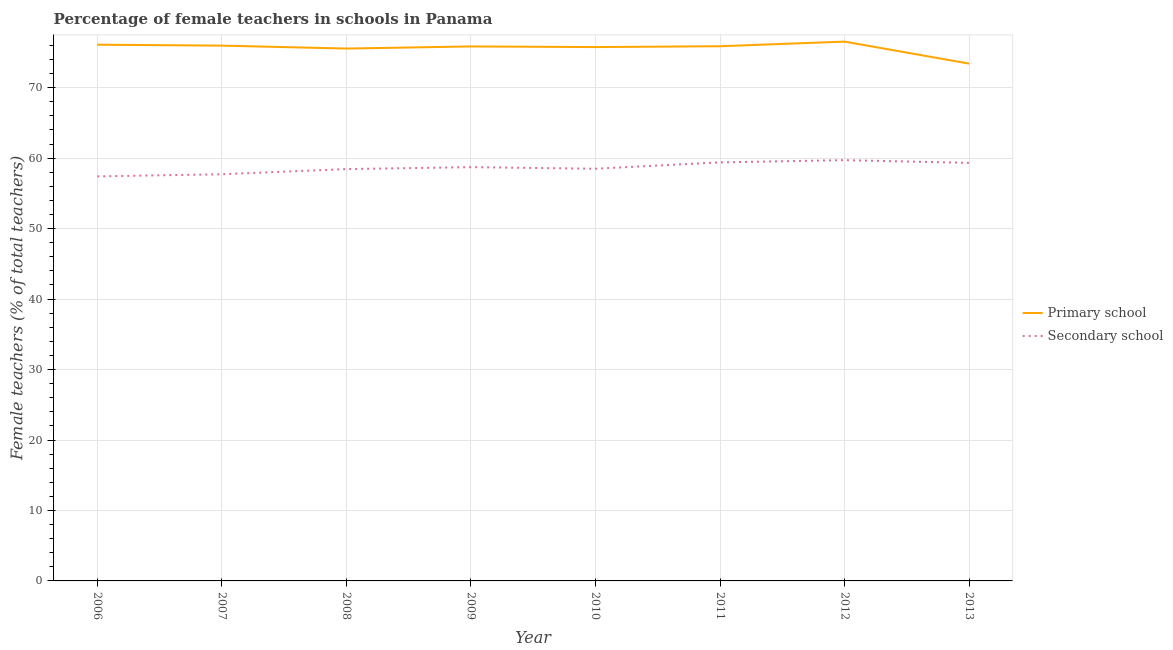What is the percentage of female teachers in secondary schools in 2010?
Offer a terse response. 58.5. Across all years, what is the maximum percentage of female teachers in primary schools?
Provide a short and direct response. 76.54. Across all years, what is the minimum percentage of female teachers in primary schools?
Your answer should be very brief. 73.42. What is the total percentage of female teachers in primary schools in the graph?
Give a very brief answer. 605.1. What is the difference between the percentage of female teachers in primary schools in 2007 and that in 2011?
Your answer should be very brief. 0.09. What is the difference between the percentage of female teachers in primary schools in 2006 and the percentage of female teachers in secondary schools in 2013?
Make the answer very short. 16.77. What is the average percentage of female teachers in primary schools per year?
Your answer should be very brief. 75.64. In the year 2012, what is the difference between the percentage of female teachers in primary schools and percentage of female teachers in secondary schools?
Your answer should be compact. 16.82. What is the ratio of the percentage of female teachers in secondary schools in 2010 to that in 2011?
Offer a very short reply. 0.98. Is the percentage of female teachers in secondary schools in 2007 less than that in 2008?
Provide a short and direct response. Yes. Is the difference between the percentage of female teachers in primary schools in 2009 and 2012 greater than the difference between the percentage of female teachers in secondary schools in 2009 and 2012?
Provide a short and direct response. Yes. What is the difference between the highest and the second highest percentage of female teachers in secondary schools?
Provide a succinct answer. 0.32. What is the difference between the highest and the lowest percentage of female teachers in secondary schools?
Offer a very short reply. 2.31. Is the sum of the percentage of female teachers in secondary schools in 2006 and 2013 greater than the maximum percentage of female teachers in primary schools across all years?
Provide a short and direct response. Yes. Does the percentage of female teachers in secondary schools monotonically increase over the years?
Offer a terse response. No. Is the percentage of female teachers in secondary schools strictly greater than the percentage of female teachers in primary schools over the years?
Offer a very short reply. No. Is the percentage of female teachers in secondary schools strictly less than the percentage of female teachers in primary schools over the years?
Make the answer very short. Yes. What is the difference between two consecutive major ticks on the Y-axis?
Provide a succinct answer. 10. Are the values on the major ticks of Y-axis written in scientific E-notation?
Ensure brevity in your answer.  No. Does the graph contain grids?
Your answer should be very brief. Yes. What is the title of the graph?
Ensure brevity in your answer.  Percentage of female teachers in schools in Panama. What is the label or title of the X-axis?
Make the answer very short. Year. What is the label or title of the Y-axis?
Your answer should be compact. Female teachers (% of total teachers). What is the Female teachers (% of total teachers) of Primary school in 2006?
Your answer should be very brief. 76.1. What is the Female teachers (% of total teachers) of Secondary school in 2006?
Give a very brief answer. 57.41. What is the Female teachers (% of total teachers) in Primary school in 2007?
Give a very brief answer. 75.97. What is the Female teachers (% of total teachers) of Secondary school in 2007?
Ensure brevity in your answer.  57.72. What is the Female teachers (% of total teachers) in Primary school in 2008?
Your response must be concise. 75.56. What is the Female teachers (% of total teachers) of Secondary school in 2008?
Offer a very short reply. 58.45. What is the Female teachers (% of total teachers) in Primary school in 2009?
Your response must be concise. 75.86. What is the Female teachers (% of total teachers) in Secondary school in 2009?
Make the answer very short. 58.72. What is the Female teachers (% of total teachers) in Primary school in 2010?
Your answer should be compact. 75.77. What is the Female teachers (% of total teachers) in Secondary school in 2010?
Provide a short and direct response. 58.5. What is the Female teachers (% of total teachers) in Primary school in 2011?
Your answer should be very brief. 75.88. What is the Female teachers (% of total teachers) in Secondary school in 2011?
Your answer should be very brief. 59.4. What is the Female teachers (% of total teachers) in Primary school in 2012?
Keep it short and to the point. 76.54. What is the Female teachers (% of total teachers) of Secondary school in 2012?
Your answer should be compact. 59.72. What is the Female teachers (% of total teachers) of Primary school in 2013?
Your answer should be compact. 73.42. What is the Female teachers (% of total teachers) in Secondary school in 2013?
Provide a succinct answer. 59.33. Across all years, what is the maximum Female teachers (% of total teachers) in Primary school?
Keep it short and to the point. 76.54. Across all years, what is the maximum Female teachers (% of total teachers) in Secondary school?
Your answer should be very brief. 59.72. Across all years, what is the minimum Female teachers (% of total teachers) of Primary school?
Your response must be concise. 73.42. Across all years, what is the minimum Female teachers (% of total teachers) in Secondary school?
Your answer should be very brief. 57.41. What is the total Female teachers (% of total teachers) of Primary school in the graph?
Your answer should be very brief. 605.1. What is the total Female teachers (% of total teachers) in Secondary school in the graph?
Ensure brevity in your answer.  469.26. What is the difference between the Female teachers (% of total teachers) in Primary school in 2006 and that in 2007?
Offer a very short reply. 0.13. What is the difference between the Female teachers (% of total teachers) in Secondary school in 2006 and that in 2007?
Your answer should be very brief. -0.31. What is the difference between the Female teachers (% of total teachers) of Primary school in 2006 and that in 2008?
Give a very brief answer. 0.55. What is the difference between the Female teachers (% of total teachers) in Secondary school in 2006 and that in 2008?
Give a very brief answer. -1.04. What is the difference between the Female teachers (% of total teachers) in Primary school in 2006 and that in 2009?
Your answer should be compact. 0.25. What is the difference between the Female teachers (% of total teachers) in Secondary school in 2006 and that in 2009?
Offer a terse response. -1.31. What is the difference between the Female teachers (% of total teachers) of Primary school in 2006 and that in 2010?
Give a very brief answer. 0.34. What is the difference between the Female teachers (% of total teachers) of Secondary school in 2006 and that in 2010?
Keep it short and to the point. -1.09. What is the difference between the Female teachers (% of total teachers) in Primary school in 2006 and that in 2011?
Ensure brevity in your answer.  0.22. What is the difference between the Female teachers (% of total teachers) of Secondary school in 2006 and that in 2011?
Your answer should be very brief. -1.99. What is the difference between the Female teachers (% of total teachers) in Primary school in 2006 and that in 2012?
Make the answer very short. -0.44. What is the difference between the Female teachers (% of total teachers) in Secondary school in 2006 and that in 2012?
Make the answer very short. -2.31. What is the difference between the Female teachers (% of total teachers) of Primary school in 2006 and that in 2013?
Provide a short and direct response. 2.68. What is the difference between the Female teachers (% of total teachers) in Secondary school in 2006 and that in 2013?
Offer a very short reply. -1.92. What is the difference between the Female teachers (% of total teachers) of Primary school in 2007 and that in 2008?
Make the answer very short. 0.42. What is the difference between the Female teachers (% of total teachers) of Secondary school in 2007 and that in 2008?
Give a very brief answer. -0.73. What is the difference between the Female teachers (% of total teachers) in Primary school in 2007 and that in 2009?
Provide a short and direct response. 0.12. What is the difference between the Female teachers (% of total teachers) in Secondary school in 2007 and that in 2009?
Provide a succinct answer. -1.01. What is the difference between the Female teachers (% of total teachers) in Primary school in 2007 and that in 2010?
Ensure brevity in your answer.  0.21. What is the difference between the Female teachers (% of total teachers) of Secondary school in 2007 and that in 2010?
Your answer should be very brief. -0.78. What is the difference between the Female teachers (% of total teachers) in Primary school in 2007 and that in 2011?
Give a very brief answer. 0.09. What is the difference between the Female teachers (% of total teachers) of Secondary school in 2007 and that in 2011?
Ensure brevity in your answer.  -1.68. What is the difference between the Female teachers (% of total teachers) in Primary school in 2007 and that in 2012?
Your answer should be very brief. -0.57. What is the difference between the Female teachers (% of total teachers) of Secondary school in 2007 and that in 2012?
Give a very brief answer. -2. What is the difference between the Female teachers (% of total teachers) in Primary school in 2007 and that in 2013?
Your answer should be compact. 2.55. What is the difference between the Female teachers (% of total teachers) in Secondary school in 2007 and that in 2013?
Your response must be concise. -1.61. What is the difference between the Female teachers (% of total teachers) in Primary school in 2008 and that in 2009?
Offer a very short reply. -0.3. What is the difference between the Female teachers (% of total teachers) in Secondary school in 2008 and that in 2009?
Offer a terse response. -0.27. What is the difference between the Female teachers (% of total teachers) of Primary school in 2008 and that in 2010?
Ensure brevity in your answer.  -0.21. What is the difference between the Female teachers (% of total teachers) of Secondary school in 2008 and that in 2010?
Your answer should be compact. -0.05. What is the difference between the Female teachers (% of total teachers) of Primary school in 2008 and that in 2011?
Give a very brief answer. -0.33. What is the difference between the Female teachers (% of total teachers) of Secondary school in 2008 and that in 2011?
Your answer should be very brief. -0.95. What is the difference between the Female teachers (% of total teachers) of Primary school in 2008 and that in 2012?
Your answer should be compact. -0.99. What is the difference between the Female teachers (% of total teachers) of Secondary school in 2008 and that in 2012?
Provide a short and direct response. -1.27. What is the difference between the Female teachers (% of total teachers) of Primary school in 2008 and that in 2013?
Your answer should be very brief. 2.14. What is the difference between the Female teachers (% of total teachers) of Secondary school in 2008 and that in 2013?
Offer a very short reply. -0.88. What is the difference between the Female teachers (% of total teachers) of Primary school in 2009 and that in 2010?
Make the answer very short. 0.09. What is the difference between the Female teachers (% of total teachers) of Secondary school in 2009 and that in 2010?
Ensure brevity in your answer.  0.22. What is the difference between the Female teachers (% of total teachers) in Primary school in 2009 and that in 2011?
Ensure brevity in your answer.  -0.03. What is the difference between the Female teachers (% of total teachers) of Secondary school in 2009 and that in 2011?
Your answer should be compact. -0.68. What is the difference between the Female teachers (% of total teachers) in Primary school in 2009 and that in 2012?
Offer a terse response. -0.68. What is the difference between the Female teachers (% of total teachers) in Secondary school in 2009 and that in 2012?
Your answer should be compact. -0.99. What is the difference between the Female teachers (% of total teachers) of Primary school in 2009 and that in 2013?
Make the answer very short. 2.44. What is the difference between the Female teachers (% of total teachers) of Secondary school in 2009 and that in 2013?
Your answer should be compact. -0.61. What is the difference between the Female teachers (% of total teachers) in Primary school in 2010 and that in 2011?
Your answer should be very brief. -0.12. What is the difference between the Female teachers (% of total teachers) of Secondary school in 2010 and that in 2011?
Give a very brief answer. -0.9. What is the difference between the Female teachers (% of total teachers) in Primary school in 2010 and that in 2012?
Keep it short and to the point. -0.78. What is the difference between the Female teachers (% of total teachers) of Secondary school in 2010 and that in 2012?
Keep it short and to the point. -1.22. What is the difference between the Female teachers (% of total teachers) in Primary school in 2010 and that in 2013?
Keep it short and to the point. 2.35. What is the difference between the Female teachers (% of total teachers) in Secondary school in 2010 and that in 2013?
Give a very brief answer. -0.83. What is the difference between the Female teachers (% of total teachers) of Primary school in 2011 and that in 2012?
Offer a terse response. -0.66. What is the difference between the Female teachers (% of total teachers) of Secondary school in 2011 and that in 2012?
Your response must be concise. -0.32. What is the difference between the Female teachers (% of total teachers) of Primary school in 2011 and that in 2013?
Provide a short and direct response. 2.46. What is the difference between the Female teachers (% of total teachers) in Secondary school in 2011 and that in 2013?
Make the answer very short. 0.07. What is the difference between the Female teachers (% of total teachers) of Primary school in 2012 and that in 2013?
Keep it short and to the point. 3.12. What is the difference between the Female teachers (% of total teachers) in Secondary school in 2012 and that in 2013?
Give a very brief answer. 0.39. What is the difference between the Female teachers (% of total teachers) of Primary school in 2006 and the Female teachers (% of total teachers) of Secondary school in 2007?
Your answer should be very brief. 18.38. What is the difference between the Female teachers (% of total teachers) of Primary school in 2006 and the Female teachers (% of total teachers) of Secondary school in 2008?
Ensure brevity in your answer.  17.65. What is the difference between the Female teachers (% of total teachers) of Primary school in 2006 and the Female teachers (% of total teachers) of Secondary school in 2009?
Your answer should be very brief. 17.38. What is the difference between the Female teachers (% of total teachers) in Primary school in 2006 and the Female teachers (% of total teachers) in Secondary school in 2010?
Ensure brevity in your answer.  17.6. What is the difference between the Female teachers (% of total teachers) in Primary school in 2006 and the Female teachers (% of total teachers) in Secondary school in 2011?
Your answer should be compact. 16.7. What is the difference between the Female teachers (% of total teachers) in Primary school in 2006 and the Female teachers (% of total teachers) in Secondary school in 2012?
Provide a succinct answer. 16.39. What is the difference between the Female teachers (% of total teachers) in Primary school in 2006 and the Female teachers (% of total teachers) in Secondary school in 2013?
Give a very brief answer. 16.77. What is the difference between the Female teachers (% of total teachers) of Primary school in 2007 and the Female teachers (% of total teachers) of Secondary school in 2008?
Offer a very short reply. 17.52. What is the difference between the Female teachers (% of total teachers) in Primary school in 2007 and the Female teachers (% of total teachers) in Secondary school in 2009?
Ensure brevity in your answer.  17.25. What is the difference between the Female teachers (% of total teachers) in Primary school in 2007 and the Female teachers (% of total teachers) in Secondary school in 2010?
Your response must be concise. 17.47. What is the difference between the Female teachers (% of total teachers) of Primary school in 2007 and the Female teachers (% of total teachers) of Secondary school in 2011?
Provide a succinct answer. 16.57. What is the difference between the Female teachers (% of total teachers) in Primary school in 2007 and the Female teachers (% of total teachers) in Secondary school in 2012?
Give a very brief answer. 16.25. What is the difference between the Female teachers (% of total teachers) in Primary school in 2007 and the Female teachers (% of total teachers) in Secondary school in 2013?
Provide a short and direct response. 16.64. What is the difference between the Female teachers (% of total teachers) of Primary school in 2008 and the Female teachers (% of total teachers) of Secondary school in 2009?
Offer a very short reply. 16.83. What is the difference between the Female teachers (% of total teachers) in Primary school in 2008 and the Female teachers (% of total teachers) in Secondary school in 2010?
Offer a terse response. 17.05. What is the difference between the Female teachers (% of total teachers) of Primary school in 2008 and the Female teachers (% of total teachers) of Secondary school in 2011?
Offer a very short reply. 16.15. What is the difference between the Female teachers (% of total teachers) of Primary school in 2008 and the Female teachers (% of total teachers) of Secondary school in 2012?
Ensure brevity in your answer.  15.84. What is the difference between the Female teachers (% of total teachers) of Primary school in 2008 and the Female teachers (% of total teachers) of Secondary school in 2013?
Your response must be concise. 16.22. What is the difference between the Female teachers (% of total teachers) of Primary school in 2009 and the Female teachers (% of total teachers) of Secondary school in 2010?
Your answer should be very brief. 17.36. What is the difference between the Female teachers (% of total teachers) in Primary school in 2009 and the Female teachers (% of total teachers) in Secondary school in 2011?
Give a very brief answer. 16.45. What is the difference between the Female teachers (% of total teachers) of Primary school in 2009 and the Female teachers (% of total teachers) of Secondary school in 2012?
Your answer should be compact. 16.14. What is the difference between the Female teachers (% of total teachers) of Primary school in 2009 and the Female teachers (% of total teachers) of Secondary school in 2013?
Ensure brevity in your answer.  16.52. What is the difference between the Female teachers (% of total teachers) of Primary school in 2010 and the Female teachers (% of total teachers) of Secondary school in 2011?
Ensure brevity in your answer.  16.36. What is the difference between the Female teachers (% of total teachers) in Primary school in 2010 and the Female teachers (% of total teachers) in Secondary school in 2012?
Your response must be concise. 16.05. What is the difference between the Female teachers (% of total teachers) in Primary school in 2010 and the Female teachers (% of total teachers) in Secondary school in 2013?
Your answer should be compact. 16.43. What is the difference between the Female teachers (% of total teachers) in Primary school in 2011 and the Female teachers (% of total teachers) in Secondary school in 2012?
Offer a terse response. 16.17. What is the difference between the Female teachers (% of total teachers) in Primary school in 2011 and the Female teachers (% of total teachers) in Secondary school in 2013?
Your answer should be very brief. 16.55. What is the difference between the Female teachers (% of total teachers) of Primary school in 2012 and the Female teachers (% of total teachers) of Secondary school in 2013?
Offer a very short reply. 17.21. What is the average Female teachers (% of total teachers) of Primary school per year?
Your response must be concise. 75.64. What is the average Female teachers (% of total teachers) in Secondary school per year?
Provide a succinct answer. 58.66. In the year 2006, what is the difference between the Female teachers (% of total teachers) in Primary school and Female teachers (% of total teachers) in Secondary school?
Provide a succinct answer. 18.69. In the year 2007, what is the difference between the Female teachers (% of total teachers) of Primary school and Female teachers (% of total teachers) of Secondary school?
Your response must be concise. 18.25. In the year 2008, what is the difference between the Female teachers (% of total teachers) of Primary school and Female teachers (% of total teachers) of Secondary school?
Your answer should be very brief. 17.11. In the year 2009, what is the difference between the Female teachers (% of total teachers) of Primary school and Female teachers (% of total teachers) of Secondary school?
Keep it short and to the point. 17.13. In the year 2010, what is the difference between the Female teachers (% of total teachers) in Primary school and Female teachers (% of total teachers) in Secondary school?
Offer a terse response. 17.26. In the year 2011, what is the difference between the Female teachers (% of total teachers) in Primary school and Female teachers (% of total teachers) in Secondary school?
Your answer should be compact. 16.48. In the year 2012, what is the difference between the Female teachers (% of total teachers) in Primary school and Female teachers (% of total teachers) in Secondary school?
Make the answer very short. 16.82. In the year 2013, what is the difference between the Female teachers (% of total teachers) of Primary school and Female teachers (% of total teachers) of Secondary school?
Make the answer very short. 14.09. What is the ratio of the Female teachers (% of total teachers) in Primary school in 2006 to that in 2007?
Your answer should be very brief. 1. What is the ratio of the Female teachers (% of total teachers) of Secondary school in 2006 to that in 2007?
Your answer should be very brief. 0.99. What is the ratio of the Female teachers (% of total teachers) of Primary school in 2006 to that in 2008?
Provide a short and direct response. 1.01. What is the ratio of the Female teachers (% of total teachers) in Secondary school in 2006 to that in 2008?
Offer a terse response. 0.98. What is the ratio of the Female teachers (% of total teachers) of Secondary school in 2006 to that in 2009?
Your answer should be very brief. 0.98. What is the ratio of the Female teachers (% of total teachers) of Primary school in 2006 to that in 2010?
Provide a succinct answer. 1. What is the ratio of the Female teachers (% of total teachers) in Secondary school in 2006 to that in 2010?
Offer a terse response. 0.98. What is the ratio of the Female teachers (% of total teachers) in Primary school in 2006 to that in 2011?
Your answer should be compact. 1. What is the ratio of the Female teachers (% of total teachers) of Secondary school in 2006 to that in 2011?
Provide a short and direct response. 0.97. What is the ratio of the Female teachers (% of total teachers) of Primary school in 2006 to that in 2012?
Provide a succinct answer. 0.99. What is the ratio of the Female teachers (% of total teachers) in Secondary school in 2006 to that in 2012?
Your answer should be very brief. 0.96. What is the ratio of the Female teachers (% of total teachers) of Primary school in 2006 to that in 2013?
Your answer should be very brief. 1.04. What is the ratio of the Female teachers (% of total teachers) in Secondary school in 2006 to that in 2013?
Give a very brief answer. 0.97. What is the ratio of the Female teachers (% of total teachers) of Primary school in 2007 to that in 2008?
Give a very brief answer. 1.01. What is the ratio of the Female teachers (% of total teachers) of Secondary school in 2007 to that in 2008?
Provide a short and direct response. 0.99. What is the ratio of the Female teachers (% of total teachers) of Secondary school in 2007 to that in 2009?
Offer a very short reply. 0.98. What is the ratio of the Female teachers (% of total teachers) of Secondary school in 2007 to that in 2010?
Offer a very short reply. 0.99. What is the ratio of the Female teachers (% of total teachers) in Secondary school in 2007 to that in 2011?
Your answer should be compact. 0.97. What is the ratio of the Female teachers (% of total teachers) in Primary school in 2007 to that in 2012?
Provide a succinct answer. 0.99. What is the ratio of the Female teachers (% of total teachers) of Secondary school in 2007 to that in 2012?
Ensure brevity in your answer.  0.97. What is the ratio of the Female teachers (% of total teachers) in Primary school in 2007 to that in 2013?
Provide a succinct answer. 1.03. What is the ratio of the Female teachers (% of total teachers) of Secondary school in 2007 to that in 2013?
Your answer should be very brief. 0.97. What is the ratio of the Female teachers (% of total teachers) in Secondary school in 2008 to that in 2009?
Give a very brief answer. 1. What is the ratio of the Female teachers (% of total teachers) of Primary school in 2008 to that in 2010?
Make the answer very short. 1. What is the ratio of the Female teachers (% of total teachers) in Secondary school in 2008 to that in 2010?
Give a very brief answer. 1. What is the ratio of the Female teachers (% of total teachers) in Secondary school in 2008 to that in 2011?
Your answer should be compact. 0.98. What is the ratio of the Female teachers (% of total teachers) of Primary school in 2008 to that in 2012?
Ensure brevity in your answer.  0.99. What is the ratio of the Female teachers (% of total teachers) in Secondary school in 2008 to that in 2012?
Make the answer very short. 0.98. What is the ratio of the Female teachers (% of total teachers) of Primary school in 2008 to that in 2013?
Your response must be concise. 1.03. What is the ratio of the Female teachers (% of total teachers) of Secondary school in 2008 to that in 2013?
Provide a succinct answer. 0.99. What is the ratio of the Female teachers (% of total teachers) of Primary school in 2009 to that in 2010?
Offer a terse response. 1. What is the ratio of the Female teachers (% of total teachers) of Secondary school in 2009 to that in 2012?
Provide a short and direct response. 0.98. What is the ratio of the Female teachers (% of total teachers) in Primary school in 2009 to that in 2013?
Your answer should be compact. 1.03. What is the ratio of the Female teachers (% of total teachers) of Secondary school in 2009 to that in 2013?
Offer a very short reply. 0.99. What is the ratio of the Female teachers (% of total teachers) of Secondary school in 2010 to that in 2011?
Your answer should be compact. 0.98. What is the ratio of the Female teachers (% of total teachers) in Secondary school in 2010 to that in 2012?
Provide a succinct answer. 0.98. What is the ratio of the Female teachers (% of total teachers) in Primary school in 2010 to that in 2013?
Offer a terse response. 1.03. What is the ratio of the Female teachers (% of total teachers) of Primary school in 2011 to that in 2012?
Your answer should be very brief. 0.99. What is the ratio of the Female teachers (% of total teachers) in Secondary school in 2011 to that in 2012?
Make the answer very short. 0.99. What is the ratio of the Female teachers (% of total teachers) in Primary school in 2011 to that in 2013?
Offer a very short reply. 1.03. What is the ratio of the Female teachers (% of total teachers) of Primary school in 2012 to that in 2013?
Provide a succinct answer. 1.04. What is the ratio of the Female teachers (% of total teachers) in Secondary school in 2012 to that in 2013?
Make the answer very short. 1.01. What is the difference between the highest and the second highest Female teachers (% of total teachers) of Primary school?
Make the answer very short. 0.44. What is the difference between the highest and the second highest Female teachers (% of total teachers) in Secondary school?
Ensure brevity in your answer.  0.32. What is the difference between the highest and the lowest Female teachers (% of total teachers) of Primary school?
Offer a terse response. 3.12. What is the difference between the highest and the lowest Female teachers (% of total teachers) in Secondary school?
Provide a short and direct response. 2.31. 